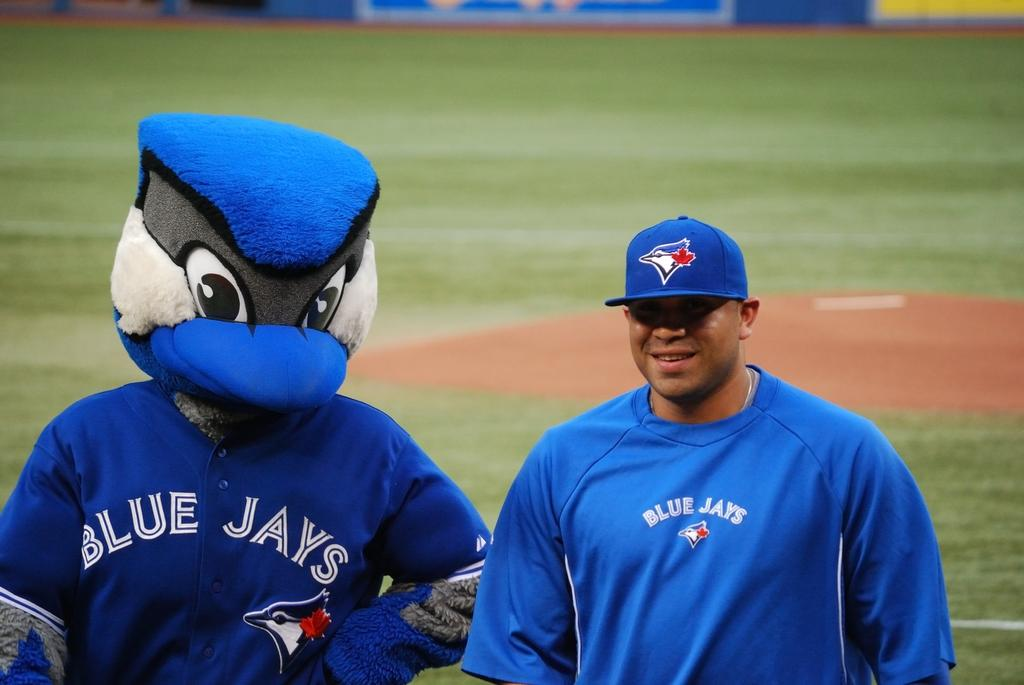<image>
Render a clear and concise summary of the photo. On a baseball field a man and a mascot walk  across the field at a Blue Jays team. 